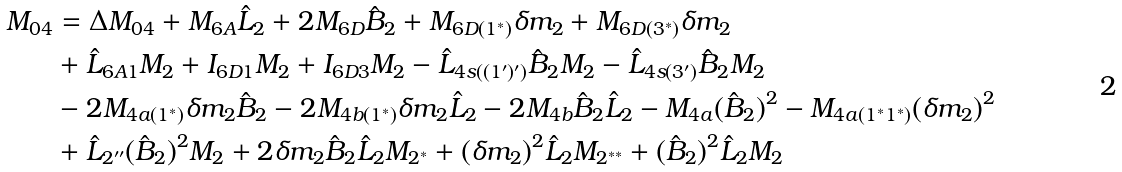Convert formula to latex. <formula><loc_0><loc_0><loc_500><loc_500>M _ { 0 4 } & = \Delta M _ { 0 4 } + M _ { 6 A } \hat { L } _ { 2 } + 2 M _ { 6 D } \hat { B } _ { 2 } + M _ { 6 D ( 1 ^ { \ast } ) } \delta m _ { 2 } + M _ { 6 D ( 3 ^ { \ast } ) } \delta m _ { 2 } \\ & + \hat { L } _ { 6 A 1 } M _ { 2 } + I _ { 6 D 1 } M _ { 2 } + I _ { 6 D 3 } M _ { 2 } - \hat { L } _ { 4 s ( ( 1 ^ { \prime } ) ^ { \prime } ) } \hat { B } _ { 2 } M _ { 2 } - \hat { L } _ { 4 s ( 3 ^ { \prime } ) } \hat { B } _ { 2 } M _ { 2 } \\ & - 2 M _ { 4 a ( 1 ^ { \ast } ) } \delta m _ { 2 } \hat { B } _ { 2 } - 2 M _ { 4 b ( 1 ^ { \ast } ) } \delta m _ { 2 } \hat { L } _ { 2 } - 2 M _ { 4 b } \hat { B } _ { 2 } \hat { L } _ { 2 } - M _ { 4 a } ( \hat { B } _ { 2 } ) ^ { 2 } - M _ { 4 a ( 1 ^ { \ast } 1 ^ { \ast } ) } ( \delta m _ { 2 } ) ^ { 2 } \\ & + \hat { L } _ { 2 ^ { \prime \prime } } ( \hat { B } _ { 2 } ) ^ { 2 } M _ { 2 } + 2 \delta m _ { 2 } \hat { B } _ { 2 } \hat { L } _ { 2 } M _ { 2 ^ { \ast } } + ( \delta m _ { 2 } ) ^ { 2 } \hat { L } _ { 2 } M _ { 2 ^ { \ast \ast } } + ( \hat { B } _ { 2 } ) ^ { 2 } \hat { L } _ { 2 } M _ { 2 }</formula> 